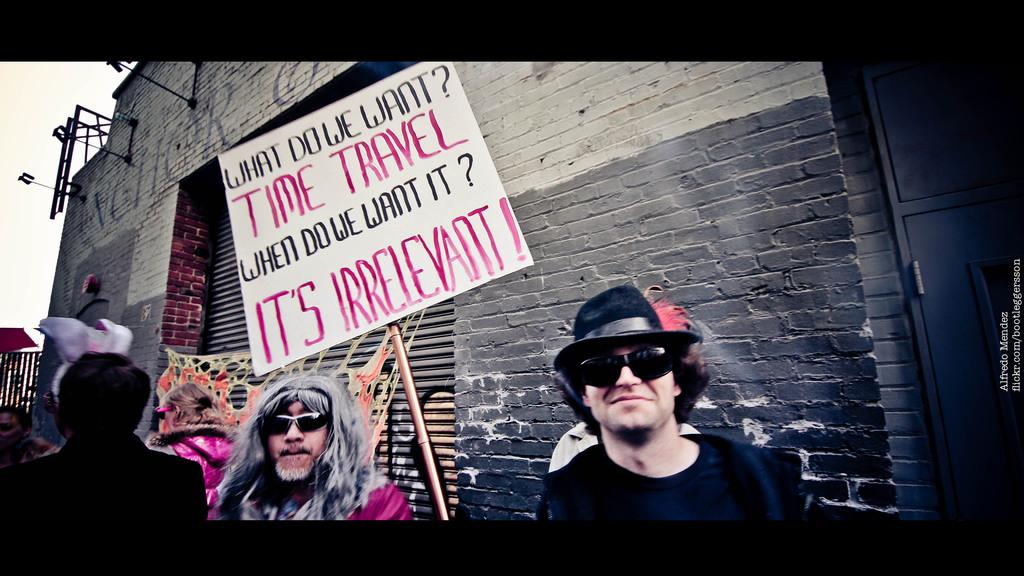What is happening in the image? There are people standing in the image. What object is being held by the people? There is a white color board fixed to a stick being held by the people. What can be seen on the color board? There is text on the board. What is visible in the background of the image? There is a wall and the sky in the background of the image. What type of dirt can be seen on the hands of the people in the image? There is no dirt visible on the hands of the people in the image. Is there any indication of a war happening in the image? There is no indication of a war in the image; it simply shows people holding a color board with text. 